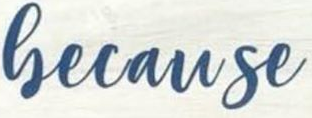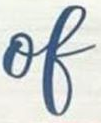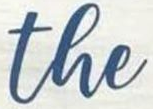What words can you see in these images in sequence, separated by a semicolon? Gecause; of; the 